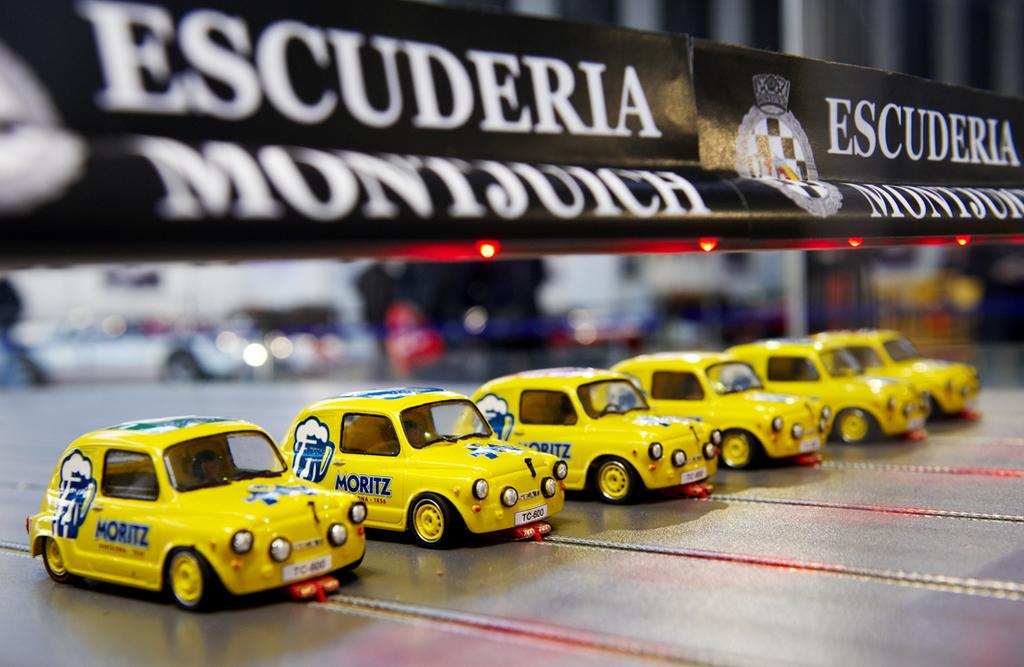What type of objects are in the image? There are toy cars in the image. How are the toy cars arranged? The toy cars are placed in a row. What else can be seen in the image besides the toy cars? There is a bar with text printed on it in the image, and electric lights are present at the bottom of the bar. What type of vegetable is growing in the cemetery in the image? There is no cemetery or vegetable present in the image. 